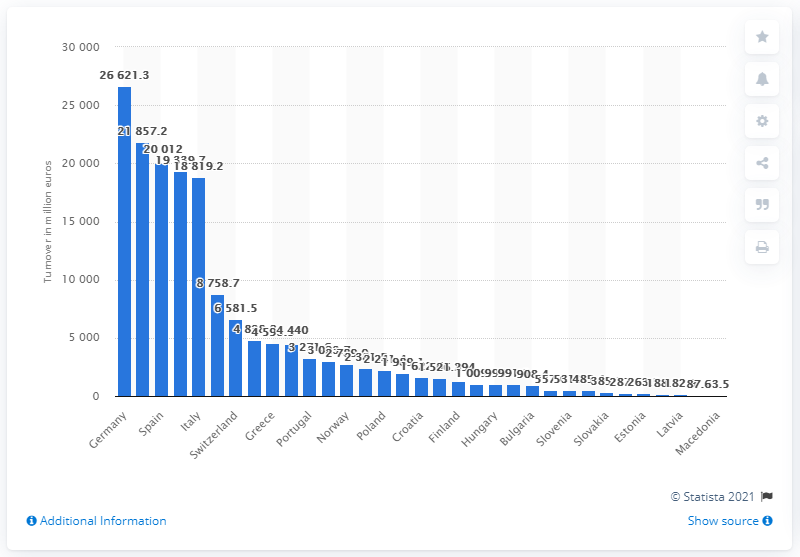Outline some significant characteristics in this image. In 2016, the total revenue generated by hotel and hotel-like accommodation services in Germany was 26,621.3 million euros. 